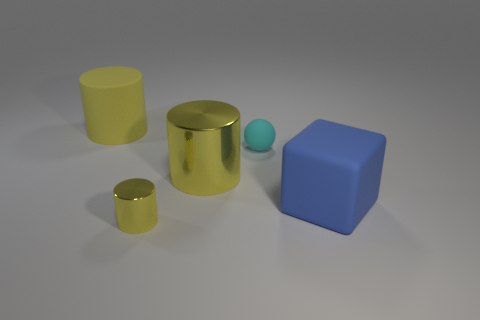Are there the same number of large blue blocks that are left of the tiny cyan matte thing and large brown shiny spheres?
Your answer should be compact. Yes. Does the cylinder that is in front of the big blue matte thing have the same material as the small object behind the large blue matte cube?
Keep it short and to the point. No. Is there anything else that is the same material as the tiny cyan ball?
Ensure brevity in your answer.  Yes. There is a big yellow object in front of the large yellow rubber object; is it the same shape as the tiny cyan object that is behind the blue matte block?
Provide a short and direct response. No. Is the number of yellow matte objects that are to the right of the big metallic cylinder less than the number of large green matte cubes?
Your answer should be very brief. No. What number of big matte cubes are the same color as the tiny sphere?
Keep it short and to the point. 0. There is a yellow object that is behind the tiny rubber object; how big is it?
Provide a short and direct response. Large. There is a yellow thing that is right of the yellow object in front of the big yellow cylinder to the right of the rubber cylinder; what shape is it?
Your answer should be very brief. Cylinder. What shape is the big object that is to the right of the tiny yellow metal object and to the left of the matte ball?
Your answer should be very brief. Cylinder. Is there a green metallic cube of the same size as the blue cube?
Provide a short and direct response. No. 